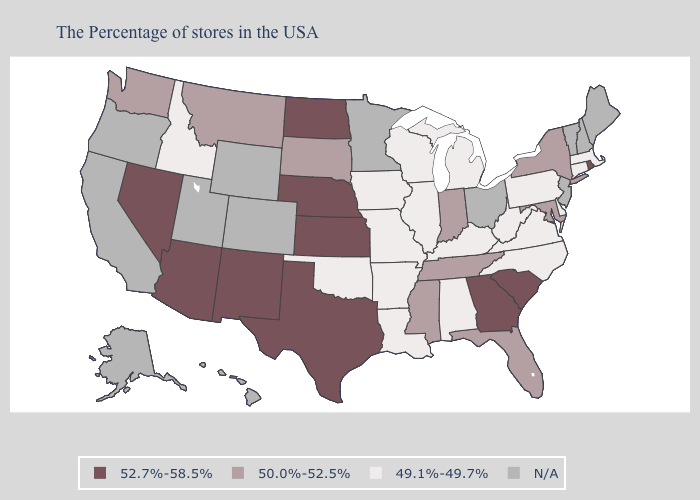Which states have the lowest value in the MidWest?
Keep it brief. Michigan, Wisconsin, Illinois, Missouri, Iowa. What is the lowest value in states that border Utah?
Give a very brief answer. 49.1%-49.7%. Name the states that have a value in the range 49.1%-49.7%?
Answer briefly. Massachusetts, Connecticut, Delaware, Pennsylvania, Virginia, North Carolina, West Virginia, Michigan, Kentucky, Alabama, Wisconsin, Illinois, Louisiana, Missouri, Arkansas, Iowa, Oklahoma, Idaho. Which states have the highest value in the USA?
Concise answer only. Rhode Island, South Carolina, Georgia, Kansas, Nebraska, Texas, North Dakota, New Mexico, Arizona, Nevada. Among the states that border Idaho , does Washington have the lowest value?
Short answer required. Yes. What is the lowest value in the USA?
Quick response, please. 49.1%-49.7%. Does Rhode Island have the lowest value in the Northeast?
Be succinct. No. Name the states that have a value in the range N/A?
Answer briefly. Maine, New Hampshire, Vermont, New Jersey, Ohio, Minnesota, Wyoming, Colorado, Utah, California, Oregon, Alaska, Hawaii. Name the states that have a value in the range 49.1%-49.7%?
Keep it brief. Massachusetts, Connecticut, Delaware, Pennsylvania, Virginia, North Carolina, West Virginia, Michigan, Kentucky, Alabama, Wisconsin, Illinois, Louisiana, Missouri, Arkansas, Iowa, Oklahoma, Idaho. Among the states that border Idaho , which have the highest value?
Quick response, please. Nevada. Which states have the highest value in the USA?
Short answer required. Rhode Island, South Carolina, Georgia, Kansas, Nebraska, Texas, North Dakota, New Mexico, Arizona, Nevada. What is the lowest value in states that border Ohio?
Give a very brief answer. 49.1%-49.7%. Which states have the lowest value in the USA?
Be succinct. Massachusetts, Connecticut, Delaware, Pennsylvania, Virginia, North Carolina, West Virginia, Michigan, Kentucky, Alabama, Wisconsin, Illinois, Louisiana, Missouri, Arkansas, Iowa, Oklahoma, Idaho. What is the value of Arizona?
Give a very brief answer. 52.7%-58.5%. 